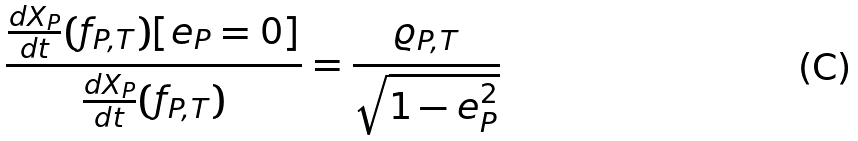<formula> <loc_0><loc_0><loc_500><loc_500>\frac { \frac { d X _ { P } } { d t } ( f _ { P , T } ) [ e _ { P } = 0 ] } { \frac { d X _ { P } } { d t } ( f _ { P , T } ) } = \frac { \varrho _ { P , T } } { \sqrt { 1 - e _ { P } ^ { 2 } } }</formula> 